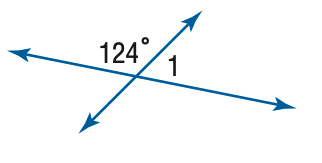Answer the mathemtical geometry problem and directly provide the correct option letter.
Question: Find the measure of \angle 1.
Choices: A: 56 B: 66 C: 76 D: 86 A 